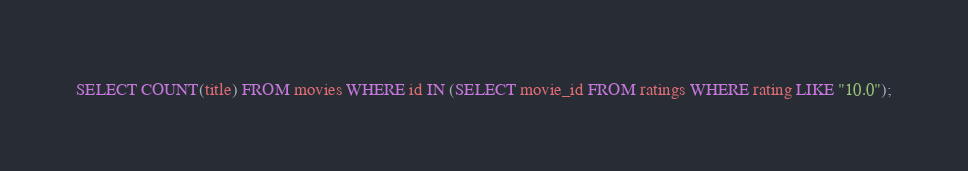<code> <loc_0><loc_0><loc_500><loc_500><_SQL_>SELECT COUNT(title) FROM movies WHERE id IN (SELECT movie_id FROM ratings WHERE rating LIKE "10.0");</code> 